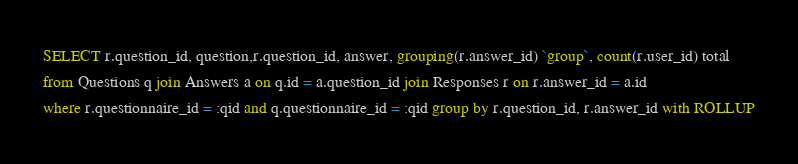<code> <loc_0><loc_0><loc_500><loc_500><_SQL_>SELECT r.question_id, question,r.question_id, answer, grouping(r.answer_id) `group`, count(r.user_id) total
from Questions q join Answers a on q.id = a.question_id join Responses r on r.answer_id = a.id
where r.questionnaire_id = :qid and q.questionnaire_id = :qid group by r.question_id, r.answer_id with ROLLUP
</code> 